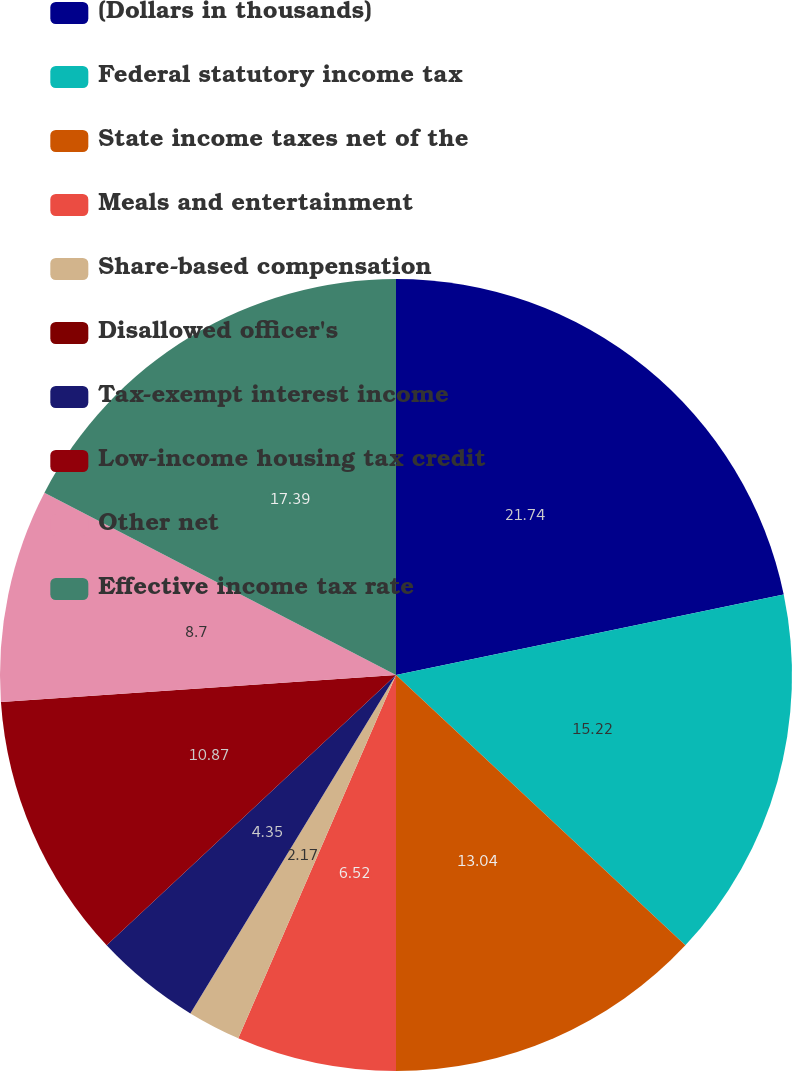Convert chart. <chart><loc_0><loc_0><loc_500><loc_500><pie_chart><fcel>(Dollars in thousands)<fcel>Federal statutory income tax<fcel>State income taxes net of the<fcel>Meals and entertainment<fcel>Share-based compensation<fcel>Disallowed officer's<fcel>Tax-exempt interest income<fcel>Low-income housing tax credit<fcel>Other net<fcel>Effective income tax rate<nl><fcel>21.74%<fcel>15.22%<fcel>13.04%<fcel>6.52%<fcel>2.17%<fcel>0.0%<fcel>4.35%<fcel>10.87%<fcel>8.7%<fcel>17.39%<nl></chart> 